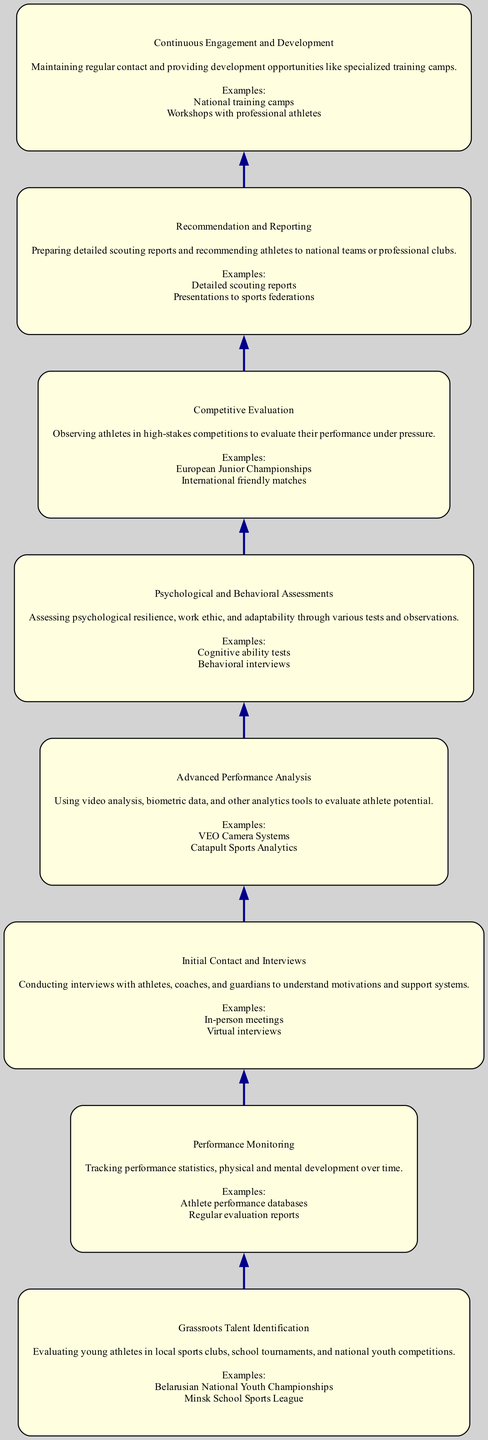What is the first step in the scouting process? The first step is "Grassroots Talent Identification," which focuses on evaluating young athletes in various local events. This is the bottom-most node in the flow chart.
Answer: Grassroots Talent Identification How many nodes are present in the diagram? The diagram contains eight nodes representing each step in the scouting process. Counting each unique step gives us the total.
Answer: Eight Which step follows "Initial Contact and Interviews"? The step that follows is "Psychological and Behavioral Assessments," as it shares a direct edge from the node above it in the flow.
Answer: Psychological and Behavioral Assessments What is the primary purpose of "Competitive Evaluation"? Its purpose is to observe athletes in high-stakes competitions to evaluate their performance under pressure, as described in its node.
Answer: Evaluate performance under pressure Which steps are directly connected to "Recommendation and Reporting"? "Continuous Engagement and Development" is connected directly above "Recommendation and Reporting" and marks the culmination of the scouting process before athlete development initiatives.
Answer: Continuous Engagement and Development How does "Performance Monitoring" relate to "Advanced Performance Analysis"? "Performance Monitoring" feeds into "Advanced Performance Analysis," indicating that the data collected in monitoring plays a crucial role in performing deeper analysis on athletes.
Answer: Performance Monitoring feeds into Advanced Performance Analysis What assessment method is used in "Psychological and Behavioral Assessments"? "Cognitive ability tests" are specifically mentioned as an example of the assessment methods used to evaluate athletes' psychological resilience.
Answer: Cognitive ability tests Which step provides athletes with development opportunities? The step titled "Continuous Engagement and Development" focuses on maintaining contact and providing specialized training opportunities for athletes.
Answer: Continuous Engagement and Development 